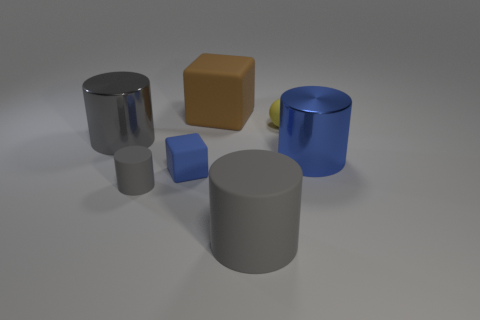Subtract all blue blocks. How many gray cylinders are left? 3 Subtract all green cylinders. Subtract all red balls. How many cylinders are left? 4 Add 2 brown rubber things. How many objects exist? 9 Subtract all cylinders. How many objects are left? 3 Add 7 tiny balls. How many tiny balls are left? 8 Add 5 rubber cylinders. How many rubber cylinders exist? 7 Subtract 0 green spheres. How many objects are left? 7 Subtract all big gray metal things. Subtract all yellow objects. How many objects are left? 5 